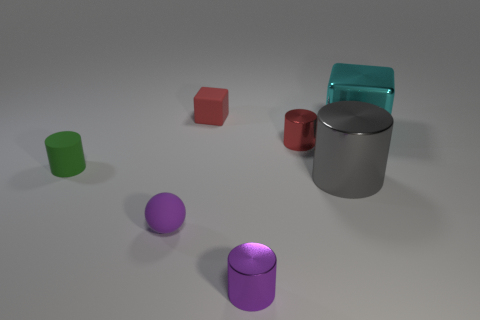Subtract 1 cylinders. How many cylinders are left? 3 Add 1 small cyan cylinders. How many objects exist? 8 Subtract all blocks. How many objects are left? 5 Subtract 1 purple cylinders. How many objects are left? 6 Subtract all big metal things. Subtract all big yellow things. How many objects are left? 5 Add 2 cyan metallic things. How many cyan metallic things are left? 3 Add 7 big gray cylinders. How many big gray cylinders exist? 8 